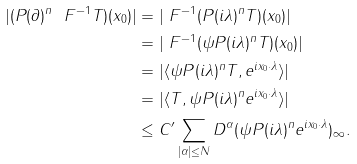Convert formula to latex. <formula><loc_0><loc_0><loc_500><loc_500>| ( P ( \partial ) ^ { n } \ F ^ { - 1 } T ) ( x _ { 0 } ) | & = | \ F ^ { - 1 } ( P ( i \lambda ) ^ { n } T ) ( x _ { 0 } ) | \\ & = | \ F ^ { - 1 } ( \psi P ( i \lambda ) ^ { n } T ) ( x _ { 0 } ) | \\ & = | \langle \psi P ( i \lambda ) ^ { n } T , e ^ { i x _ { 0 } \cdot \lambda } \rangle | \\ & = | \langle T , \psi P ( i \lambda ) ^ { n } e ^ { i x _ { 0 } \cdot \lambda } \rangle | \\ & \leq C ^ { \prime } \sum _ { | \alpha | \leq N } \| D ^ { \alpha } ( \psi P ( i \lambda ) ^ { n } e ^ { i x _ { 0 } \cdot \lambda } ) \| _ { \infty } .</formula> 